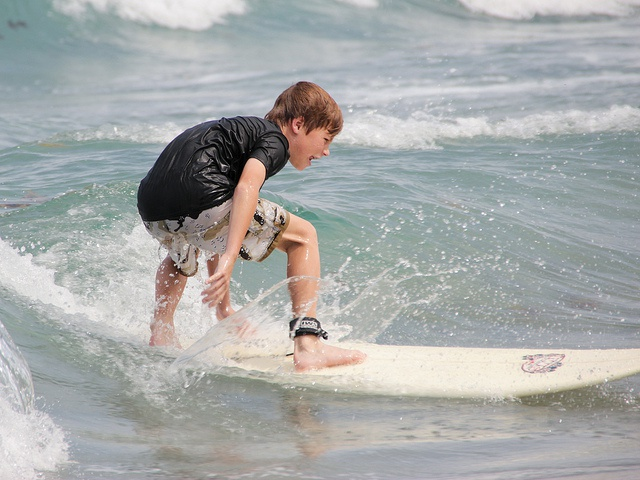Describe the objects in this image and their specific colors. I can see people in gray, black, tan, and brown tones and surfboard in gray, ivory, darkgray, and lightgray tones in this image. 